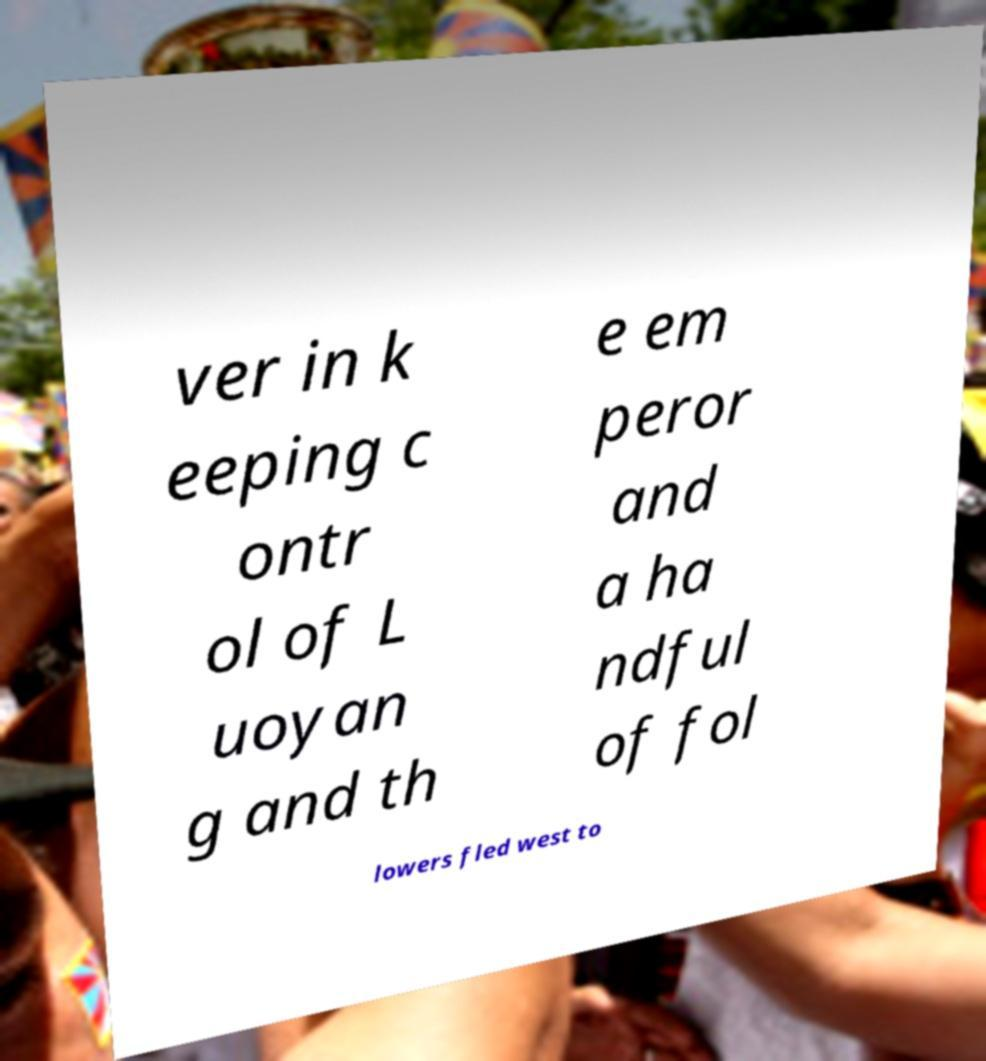Could you assist in decoding the text presented in this image and type it out clearly? ver in k eeping c ontr ol of L uoyan g and th e em peror and a ha ndful of fol lowers fled west to 